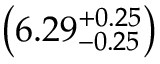<formula> <loc_0><loc_0><loc_500><loc_500>\left ( 6 . 2 9 _ { - 0 . 2 5 } ^ { + 0 . 2 5 } \right )</formula> 